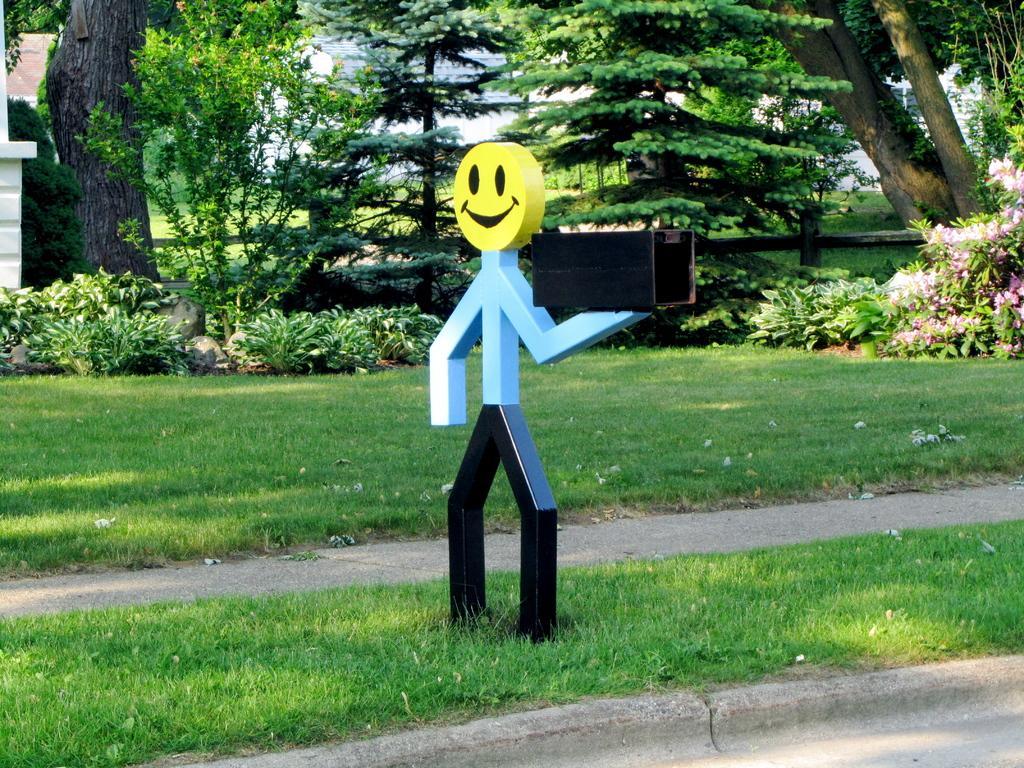Could you give a brief overview of what you see in this image? In this image I see a statue which is kind of a human and it has a smiley face and it is on the grass. In the background there are lot of plants and trees. 